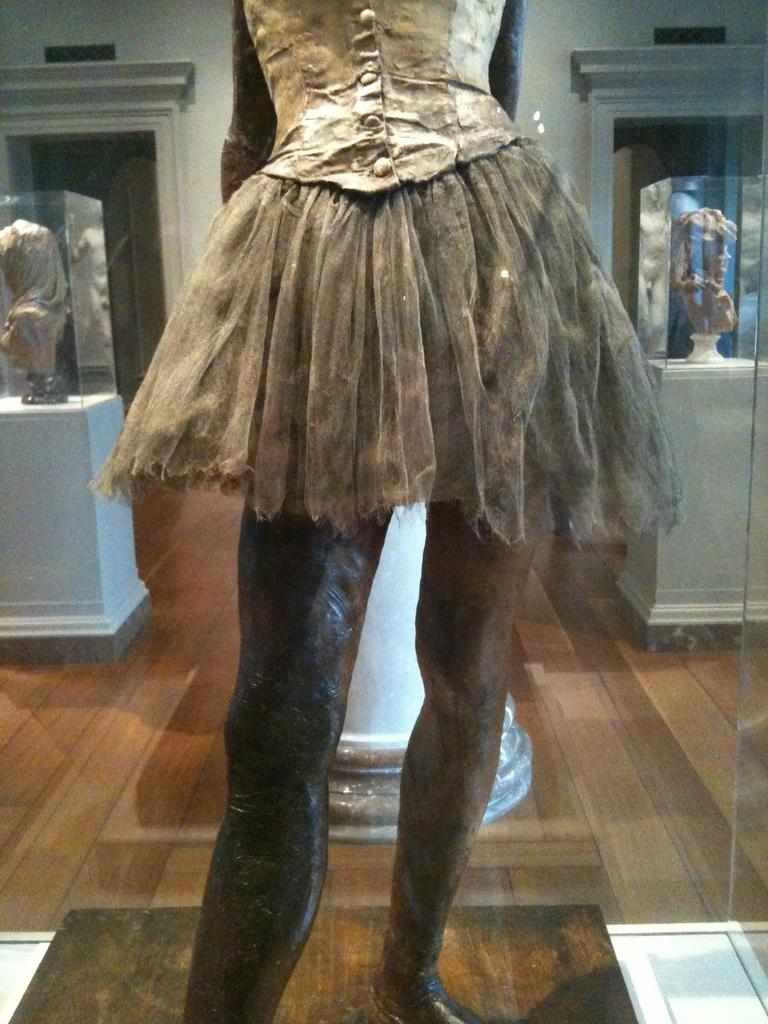What is the main subject of the image? There is a statue in the image. What is the surface on which the statue is standing? There is a floor visible in the image. What type of object can be seen in the image? There is a glass object in the image. What can be seen in the background of the image? There are glass boxes and a wall in the background of the image. What is inside the glass boxes? Sculptures are visible through the glass boxes. What type of guitar can be seen hanging on the wall in the image? There is no guitar present in the image; the wall features glass boxes with sculptures inside. How many strings are visible on the string instrument in the image? There is no string instrument present in the image. 